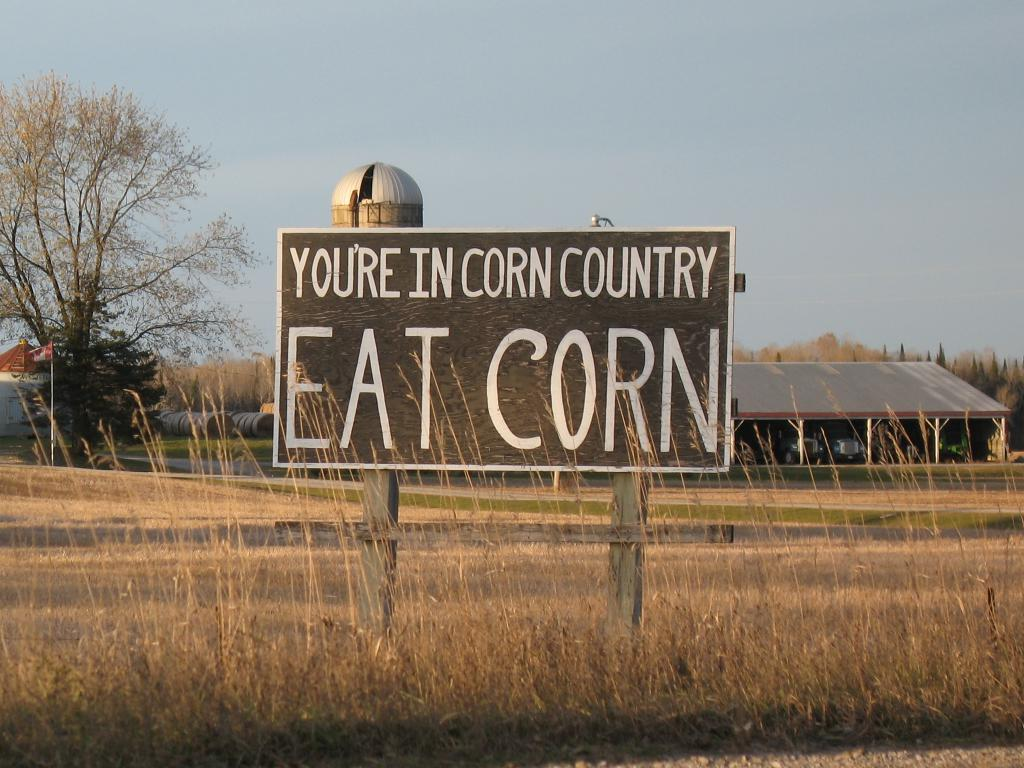What is the main subject in the center of the image? There is a board with text in the center of the image. What can be seen in the background of the image? There are buildings, the sky, and trees in the background of the image. What type of vegetation is present at the bottom of the image? Dry grass is present at the bottom of the image. What is the price of the education being offered in the image? There is no indication of any education or price in the image; it features a board with text and a background with buildings, sky, and trees. 